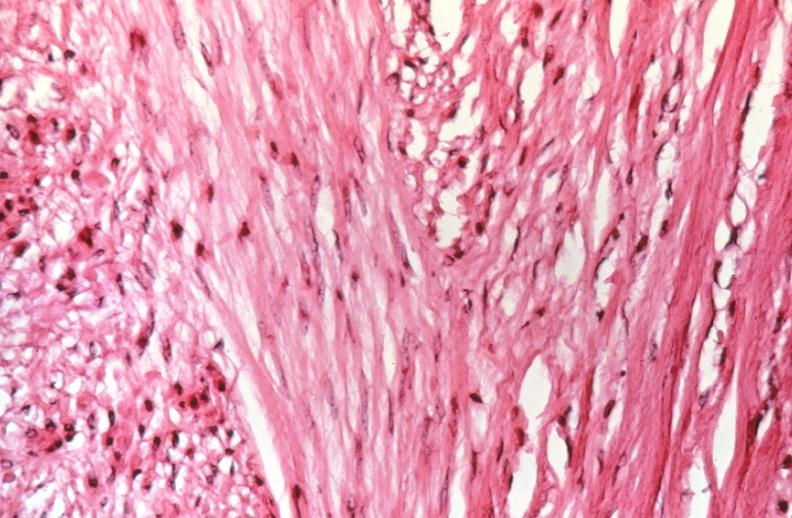s source present?
Answer the question using a single word or phrase. No 